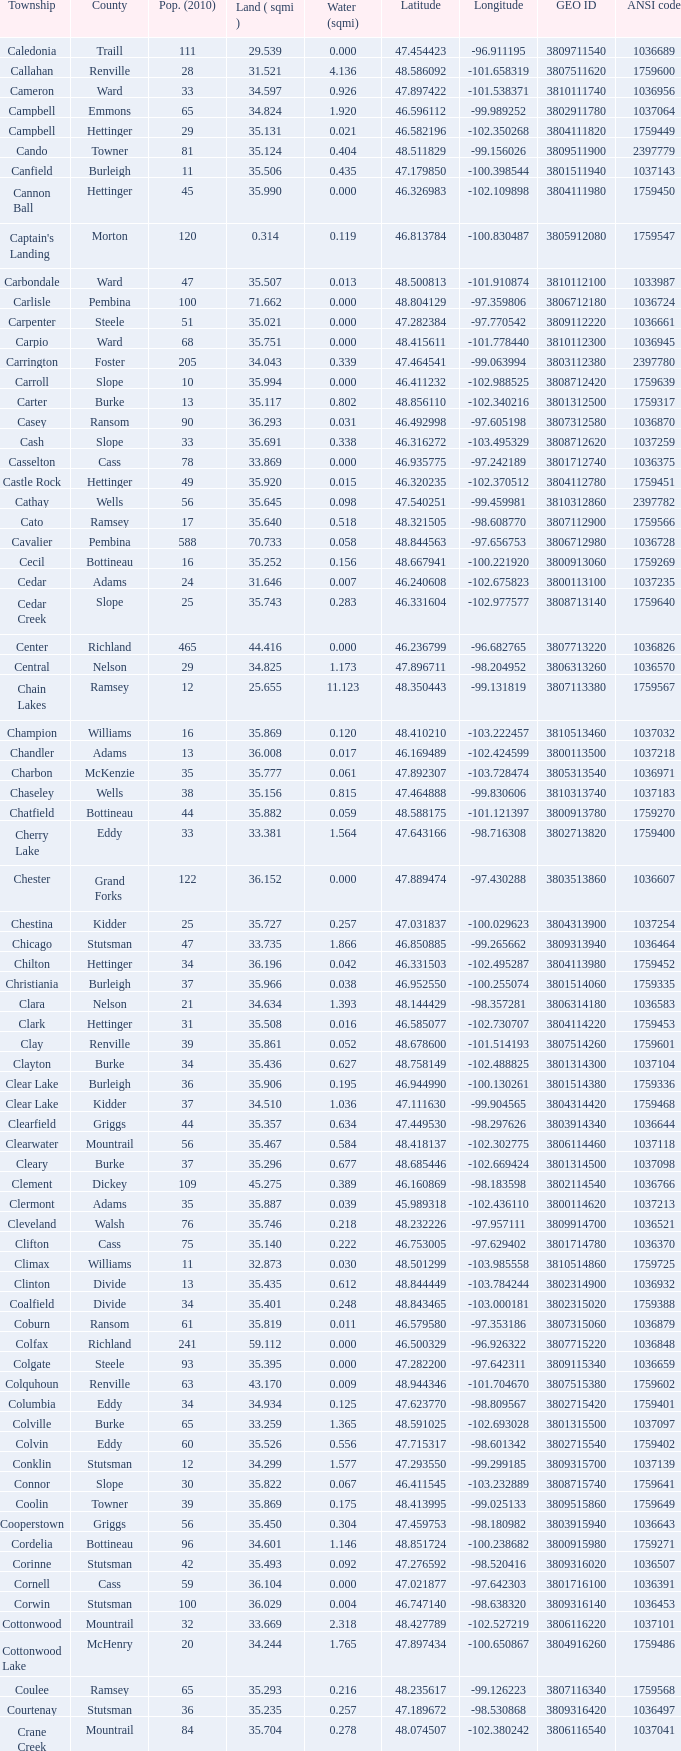763937? 35.898. 